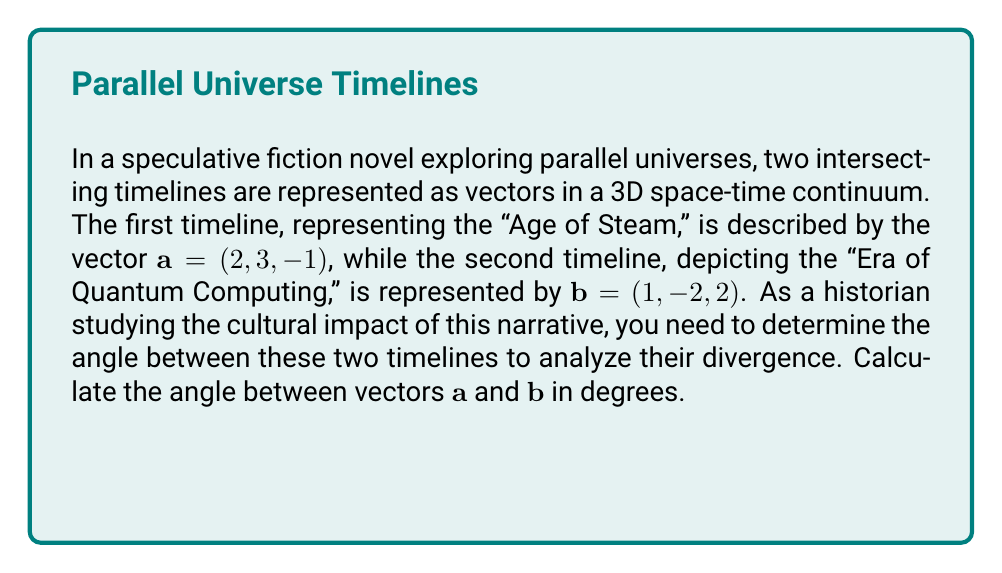Give your solution to this math problem. To find the angle between two vectors, we can use the dot product formula:

$$\cos \theta = \frac{\mathbf{a} \cdot \mathbf{b}}{|\mathbf{a}||\mathbf{b}|}$$

Step 1: Calculate the dot product $\mathbf{a} \cdot \mathbf{b}$
$$\mathbf{a} \cdot \mathbf{b} = (2)(1) + (3)(-2) + (-1)(2) = 2 - 6 - 2 = -6$$

Step 2: Calculate the magnitudes of $\mathbf{a}$ and $\mathbf{b}$
$$|\mathbf{a}| = \sqrt{2^2 + 3^2 + (-1)^2} = \sqrt{4 + 9 + 1} = \sqrt{14}$$
$$|\mathbf{b}| = \sqrt{1^2 + (-2)^2 + 2^2} = \sqrt{1 + 4 + 4} = 3$$

Step 3: Substitute into the formula
$$\cos \theta = \frac{-6}{\sqrt{14} \cdot 3} = \frac{-6}{3\sqrt{14}}$$

Step 4: Take the inverse cosine (arccos) of both sides
$$\theta = \arccos\left(\frac{-6}{3\sqrt{14}}\right)$$

Step 5: Calculate the result in degrees
$$\theta \approx 126.87°$$
Answer: $126.87°$ 